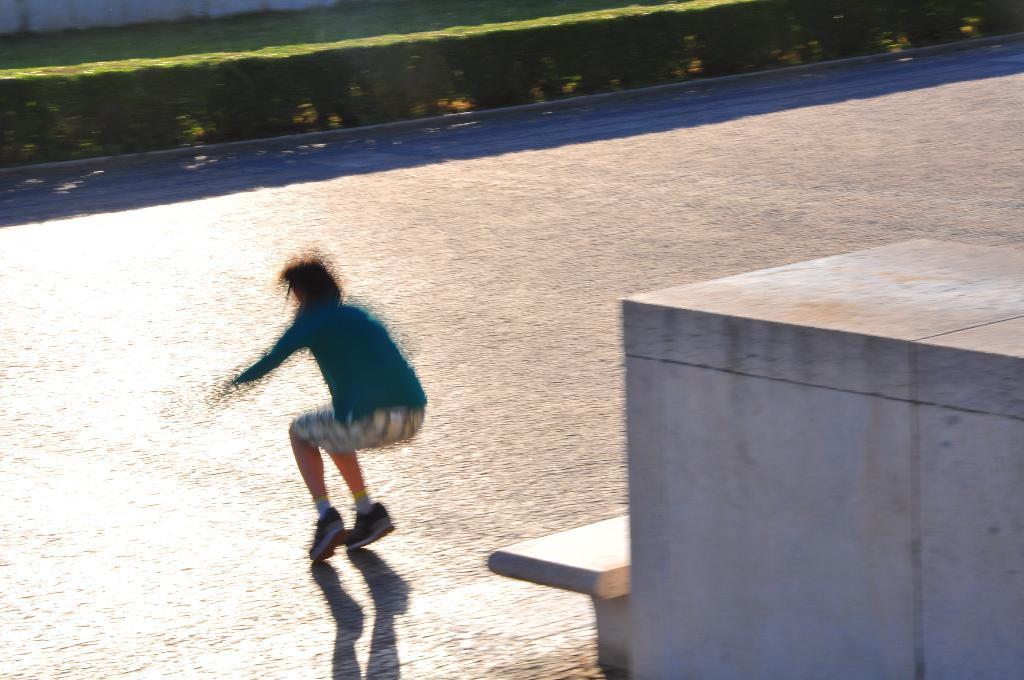Describe this image in one or two sentences. In this image I can see a bench, a person, shadows and I can see this person is wearing shorts, shoes and blue colour dress. 